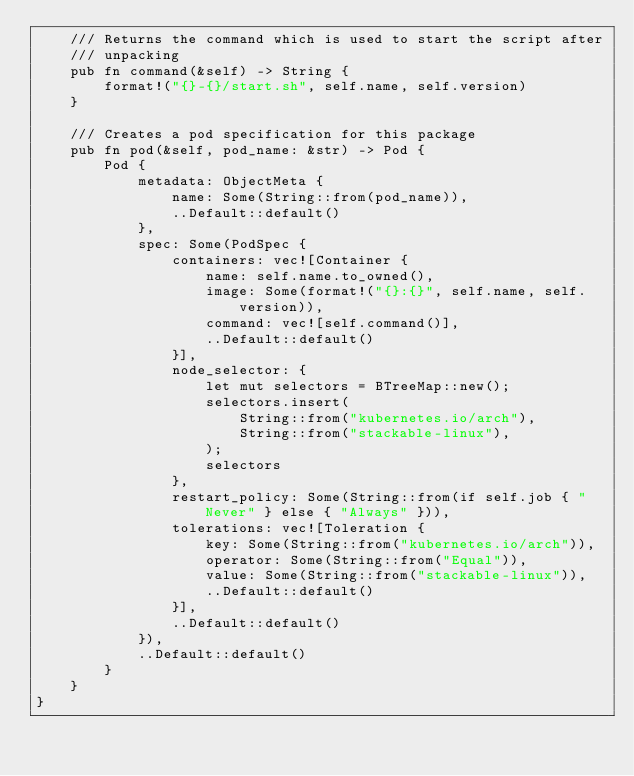<code> <loc_0><loc_0><loc_500><loc_500><_Rust_>    /// Returns the command which is used to start the script after
    /// unpacking
    pub fn command(&self) -> String {
        format!("{}-{}/start.sh", self.name, self.version)
    }

    /// Creates a pod specification for this package
    pub fn pod(&self, pod_name: &str) -> Pod {
        Pod {
            metadata: ObjectMeta {
                name: Some(String::from(pod_name)),
                ..Default::default()
            },
            spec: Some(PodSpec {
                containers: vec![Container {
                    name: self.name.to_owned(),
                    image: Some(format!("{}:{}", self.name, self.version)),
                    command: vec![self.command()],
                    ..Default::default()
                }],
                node_selector: {
                    let mut selectors = BTreeMap::new();
                    selectors.insert(
                        String::from("kubernetes.io/arch"),
                        String::from("stackable-linux"),
                    );
                    selectors
                },
                restart_policy: Some(String::from(if self.job { "Never" } else { "Always" })),
                tolerations: vec![Toleration {
                    key: Some(String::from("kubernetes.io/arch")),
                    operator: Some(String::from("Equal")),
                    value: Some(String::from("stackable-linux")),
                    ..Default::default()
                }],
                ..Default::default()
            }),
            ..Default::default()
        }
    }
}
</code> 